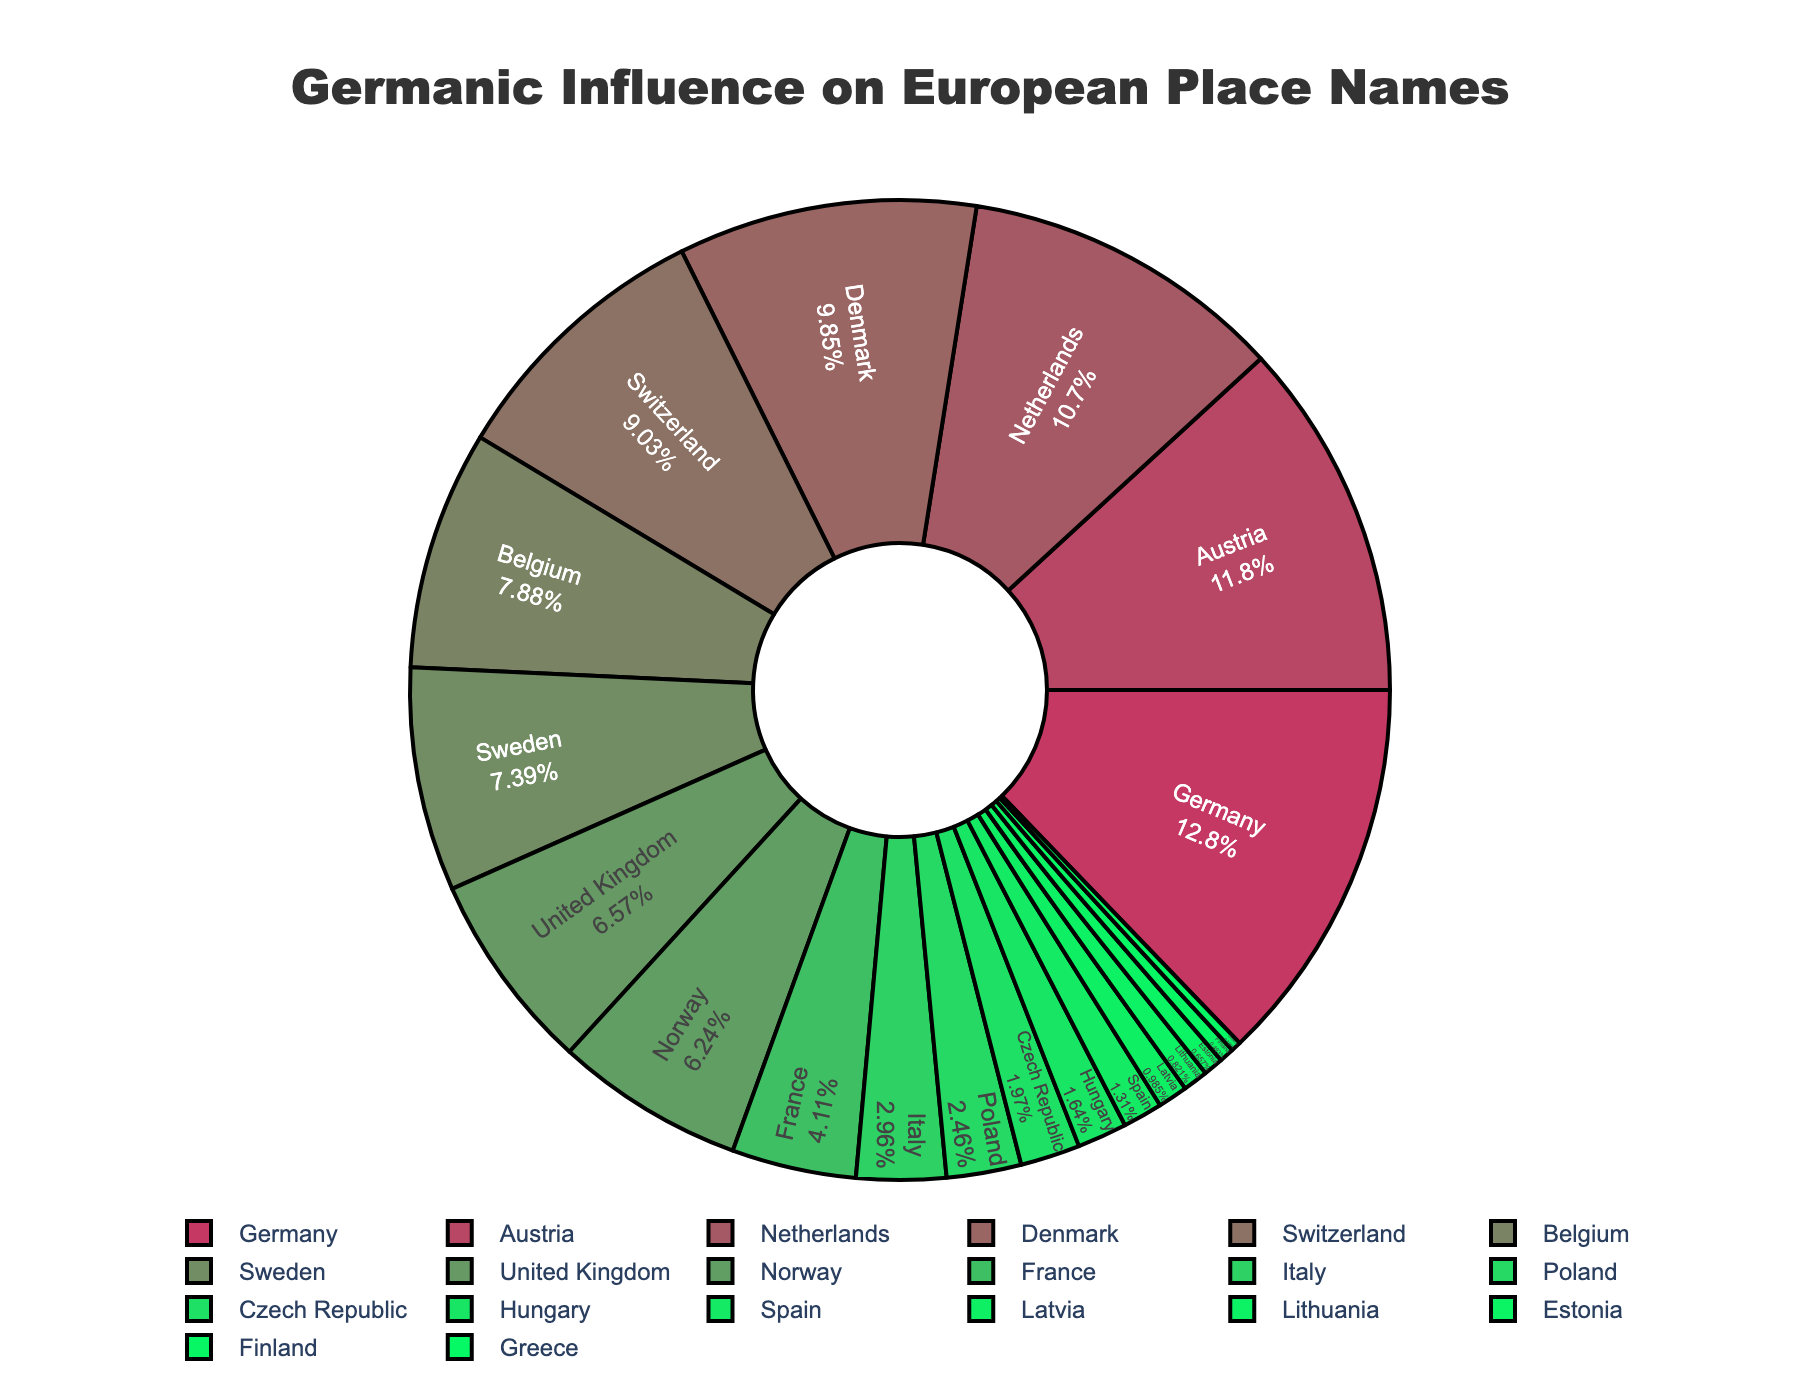Which country has the highest proportion of Germanic-influenced place names? The figure shows that Germany has the largest segment, therefore it has the highest proportion of Germanic-influenced place names at 78%.
Answer: Germany Which two countries have the smallest proportion of Germanic-influenced place names? The smallest segments in the figure correspond to Greece and Finland, which have the lowest proportions at 2% and 3% respectively.
Answer: Greece and Finland How much greater is the percentage of Germanic-influenced place names in Germany compared to Latvia? Germany has 78% and Latvia has 6% of Germanic-influenced place names. The difference is calculated as 78 - 6 = 72%.
Answer: 72% What is the range of percentages of Germanic-influenced place names in the given countries? The highest percentage is in Germany (78%) and the lowest in Greece (2%). The range is calculated as 78 - 2 = 76%.
Answer: 76% Which countries have a proportion of Germanic-influenced place names greater than 50%? The proportions of Germanic-influenced place names greater than 50% can be seen in the largest segments showing Germany (78%), Austria (72%), Netherlands (65%), Denmark (60%), and Switzerland (55%).
Answer: Germany, Austria, Netherlands, Denmark, Switzerland How do the proportions of Germanic-influenced place names in Belgium and Poland compare? Belgium has 48% and Poland has 15% of Germanic-influenced place names. Belgium's proportion is greater by 48 - 15 = 33%.
Answer: Belgium's proportion is 33% greater What is the average percentage of Germanic-influenced place names in the top five countries? The top five countries are Germany (78%), Austria (72%), Netherlands (65%), Denmark (60%), and Switzerland (55%). The average is calculated as (78 + 72 + 65 + 60 + 55) / 5 = 66%.
Answer: 66% Which country with a percentage of Germanic-influenced place names less than 20% has the highest value? Among the countries with less than 20%, Italy has the highest proportion at 18%.
Answer: Italy What proportion of Germanic-influenced place names does Estonia have? The figure indicates that the segment for Estonia shows 4% of Germanic-influenced place names.
Answer: 4% Is France's proportion of Germanic-influenced place names greater than that of the United Kingdom? France's segment shows 25%, whereas the United Kingdom's segment shows 40%. Therefore, France's proportion is less than the UK's.
Answer: No 